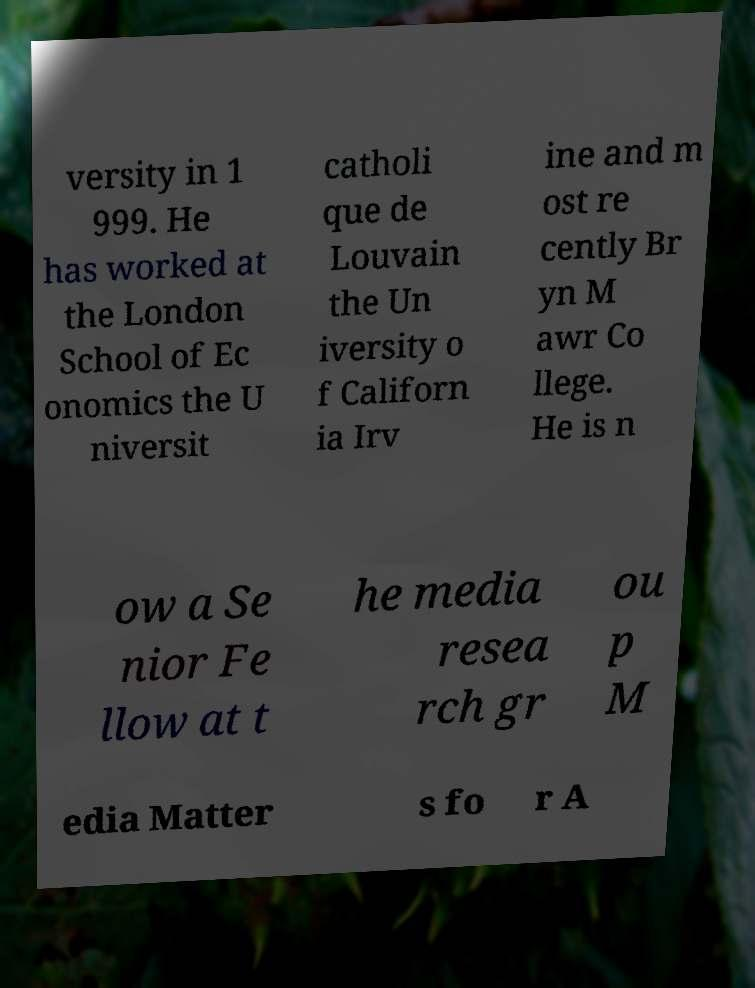Can you read and provide the text displayed in the image?This photo seems to have some interesting text. Can you extract and type it out for me? versity in 1 999. He has worked at the London School of Ec onomics the U niversit catholi que de Louvain the Un iversity o f Californ ia Irv ine and m ost re cently Br yn M awr Co llege. He is n ow a Se nior Fe llow at t he media resea rch gr ou p M edia Matter s fo r A 